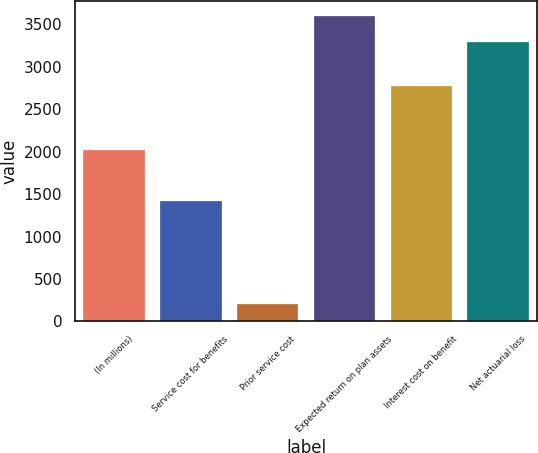Convert chart to OTSL. <chart><loc_0><loc_0><loc_500><loc_500><bar_chart><fcel>(In millions)<fcel>Service cost for benefits<fcel>Prior service cost<fcel>Expected return on plan assets<fcel>Interest cost on benefit<fcel>Net actuarial loss<nl><fcel>2015<fcel>1424<fcel>205<fcel>3597.7<fcel>2778<fcel>3288<nl></chart> 